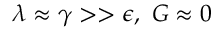Convert formula to latex. <formula><loc_0><loc_0><loc_500><loc_500>\lambda \approx \gamma > > \epsilon , \ G \approx 0</formula> 